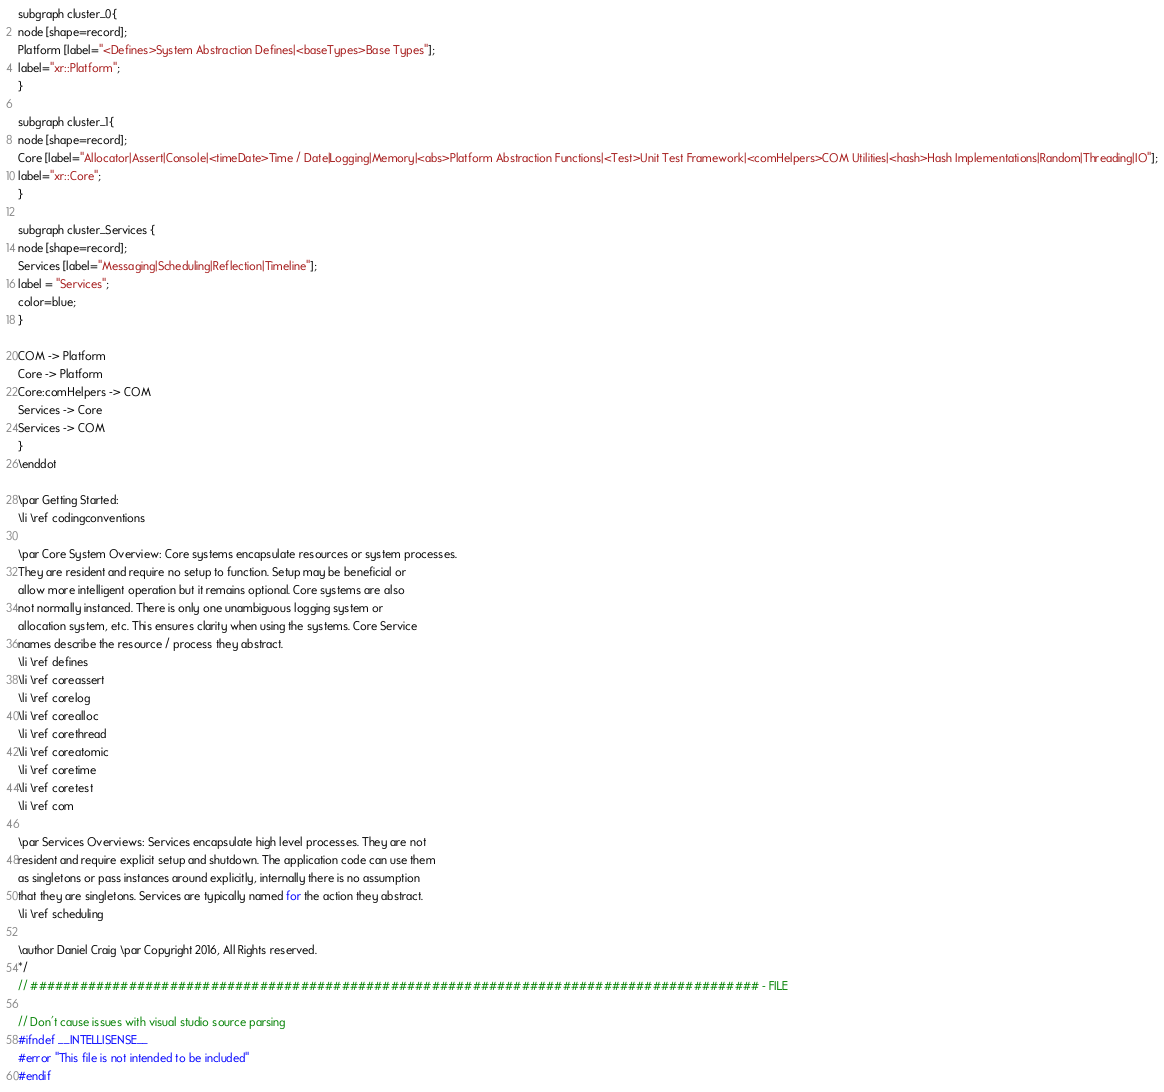Convert code to text. <code><loc_0><loc_0><loc_500><loc_500><_C_>
subgraph cluster_0{
node [shape=record];
Platform [label="<Defines>System Abstraction Defines|<baseTypes>Base Types"];
label="xr::Platform";
}

subgraph cluster_1{
node [shape=record];
Core [label="Allocator|Assert|Console|<timeDate>Time / Date|Logging|Memory|<abs>Platform Abstraction Functions|<Test>Unit Test Framework|<comHelpers>COM Utilities|<hash>Hash Implementations|Random|Threading|IO"];
label="xr::Core";
}

subgraph cluster_Services {
node [shape=record];
Services [label="Messaging|Scheduling|Reflection|Timeline"];
label = "Services";
color=blue;
}

COM -> Platform
Core -> Platform
Core:comHelpers -> COM
Services -> Core
Services -> COM
}
\enddot

\par Getting Started:
\li \ref codingconventions

\par Core System Overview: Core systems encapsulate resources or system processes.
They are resident and require no setup to function. Setup may be beneficial or
allow more intelligent operation but it remains optional. Core systems are also
not normally instanced. There is only one unambiguous logging system or
allocation system, etc. This ensures clarity when using the systems. Core Service
names describe the resource / process they abstract.
\li \ref defines
\li \ref coreassert
\li \ref corelog
\li \ref corealloc
\li \ref corethread
\li \ref coreatomic
\li \ref coretime
\li \ref coretest
\li \ref com

\par Services Overviews: Services encapsulate high level processes. They are not
resident and require explicit setup and shutdown. The application code can use them
as singletons or pass instances around explicitly, internally there is no assumption
that they are singletons. Services are typically named for the action they abstract.
\li \ref scheduling

\author Daniel Craig \par Copyright 2016, All Rights reserved.
*/
// ######################################################################################### - FILE

// Don't cause issues with visual studio source parsing
#ifndef __INTELLISENSE__
#error "This file is not intended to be included"
#endif
</code> 